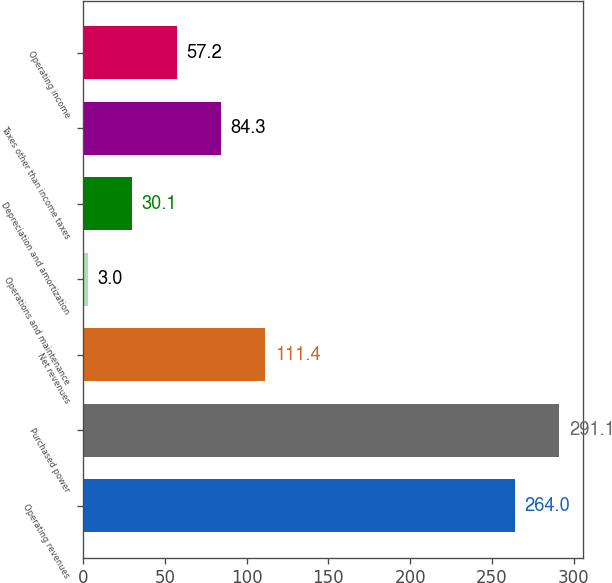Convert chart to OTSL. <chart><loc_0><loc_0><loc_500><loc_500><bar_chart><fcel>Operating revenues<fcel>Purchased power<fcel>Net revenues<fcel>Operations and maintenance<fcel>Depreciation and amortization<fcel>Taxes other than income taxes<fcel>Operating income<nl><fcel>264<fcel>291.1<fcel>111.4<fcel>3<fcel>30.1<fcel>84.3<fcel>57.2<nl></chart> 